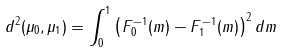<formula> <loc_0><loc_0><loc_500><loc_500>d ^ { 2 } ( \mu _ { 0 } , \mu _ { 1 } ) = \int _ { 0 } ^ { 1 } \left ( F _ { 0 } ^ { - 1 } ( m ) - F _ { 1 } ^ { - 1 } ( m ) \right ) ^ { 2 } d m</formula> 